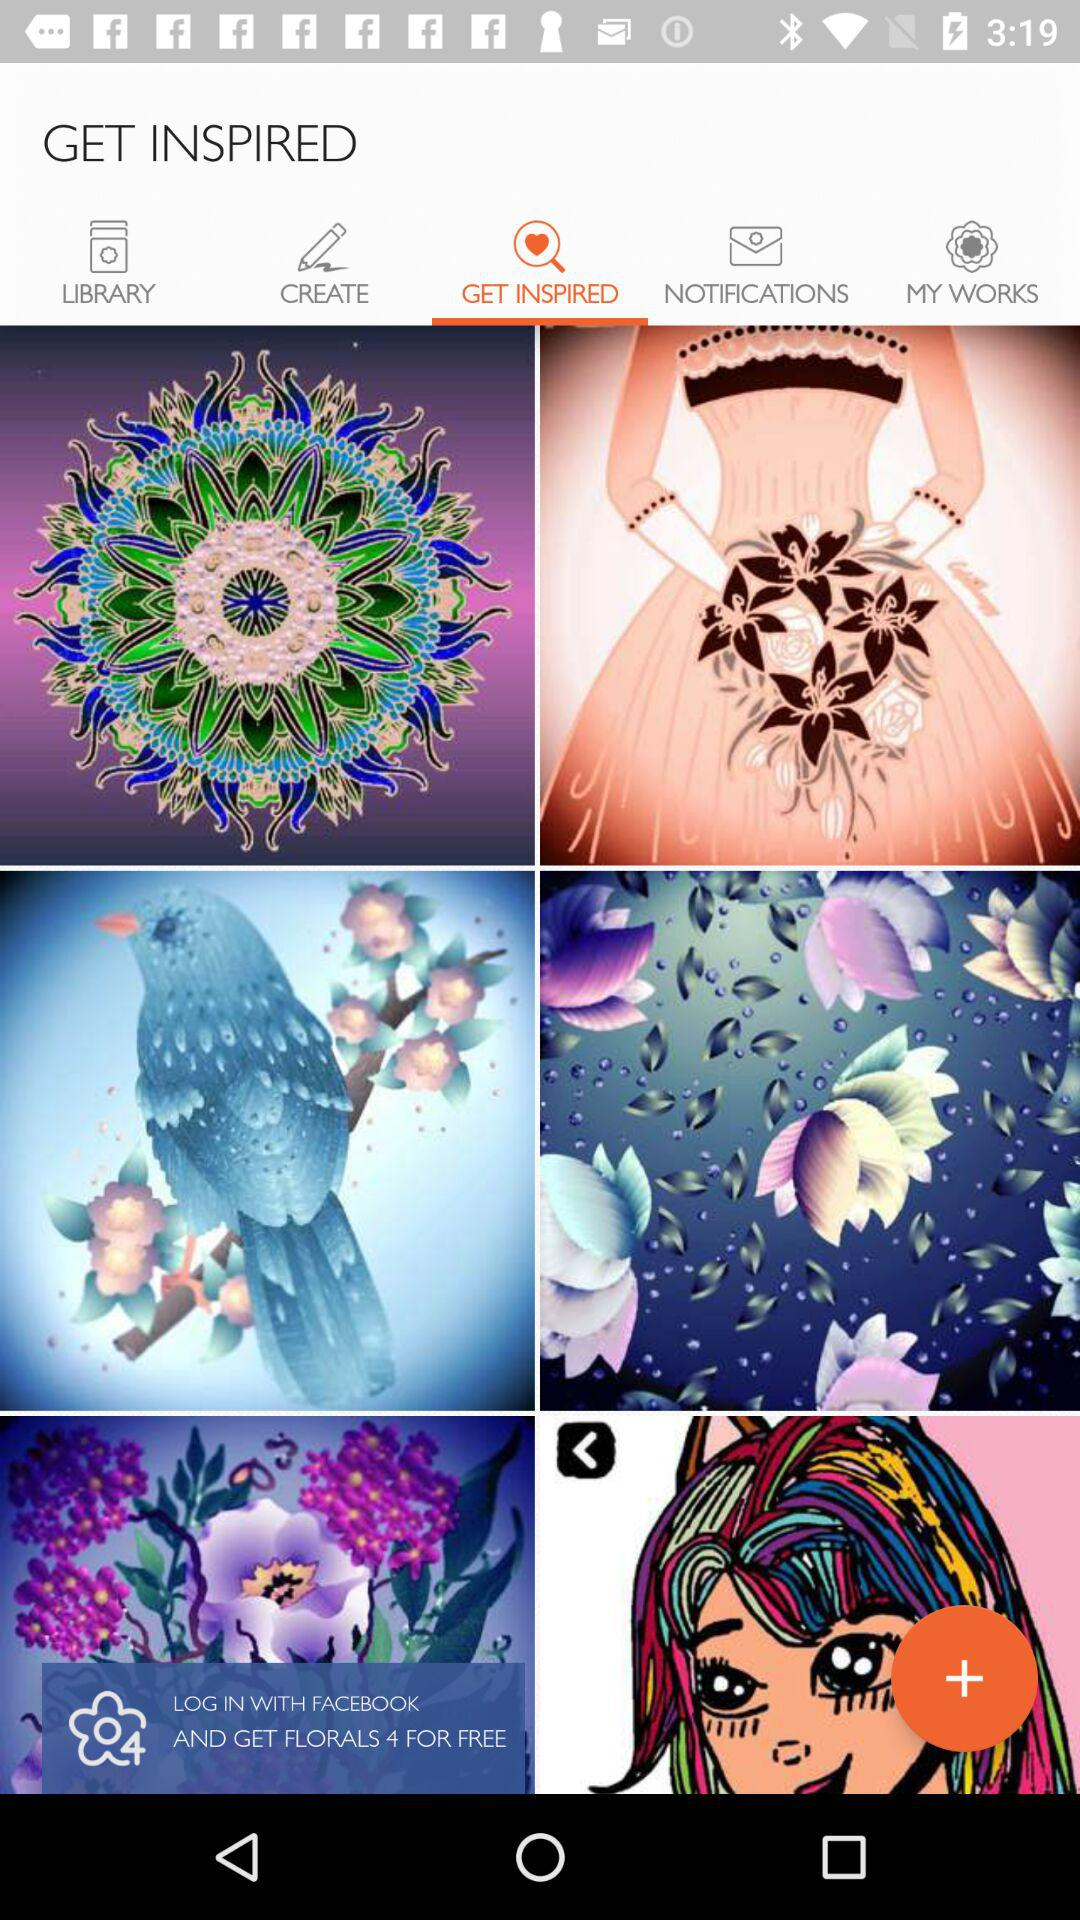Which option is selected? The selected option is "GET INSPIRED". 